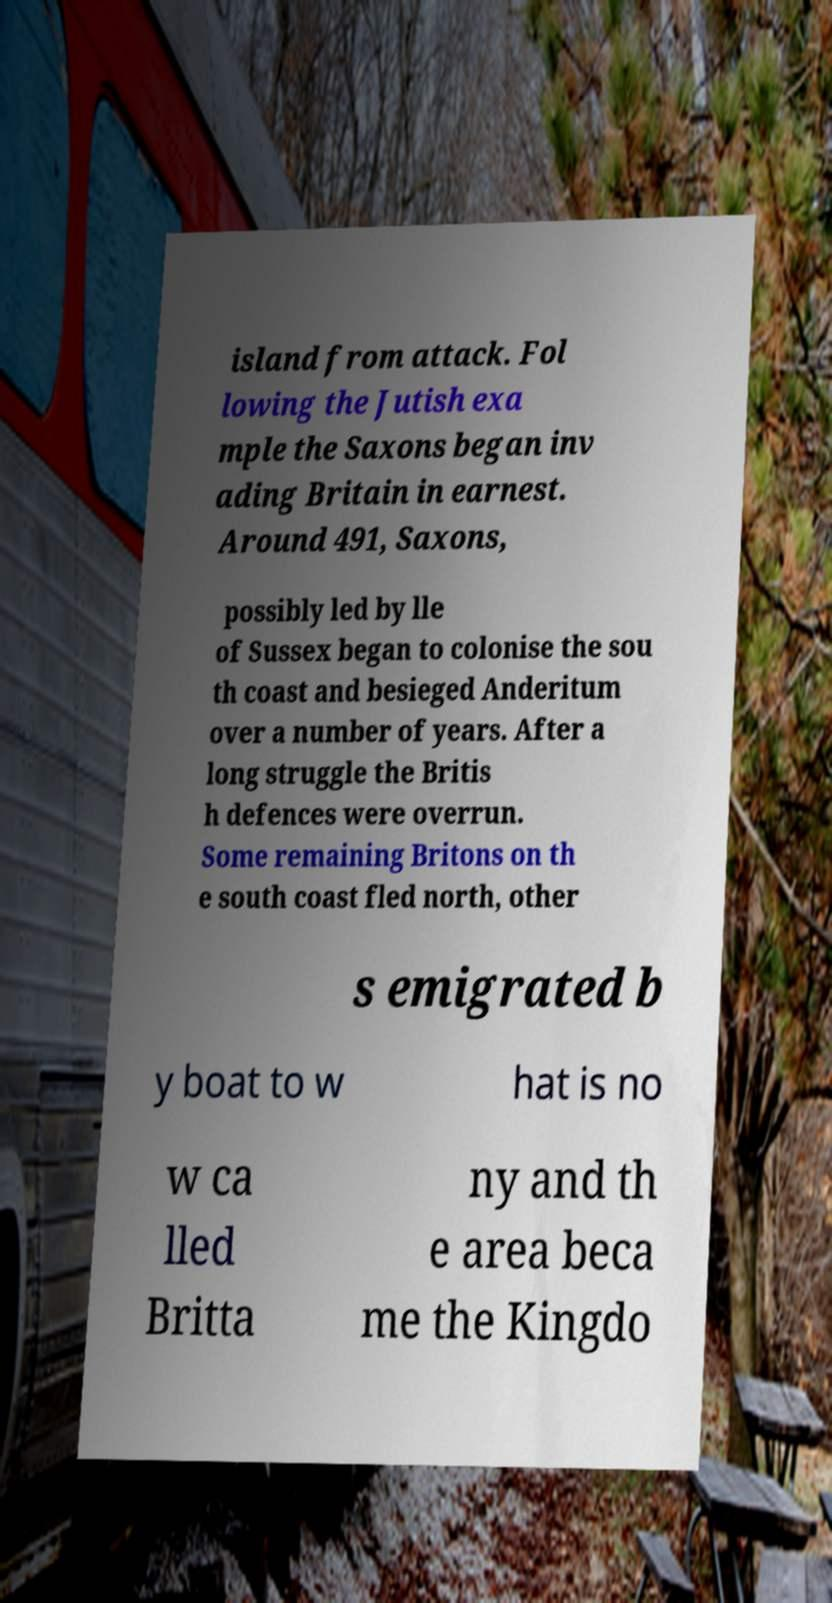Please identify and transcribe the text found in this image. island from attack. Fol lowing the Jutish exa mple the Saxons began inv ading Britain in earnest. Around 491, Saxons, possibly led by lle of Sussex began to colonise the sou th coast and besieged Anderitum over a number of years. After a long struggle the Britis h defences were overrun. Some remaining Britons on th e south coast fled north, other s emigrated b y boat to w hat is no w ca lled Britta ny and th e area beca me the Kingdo 